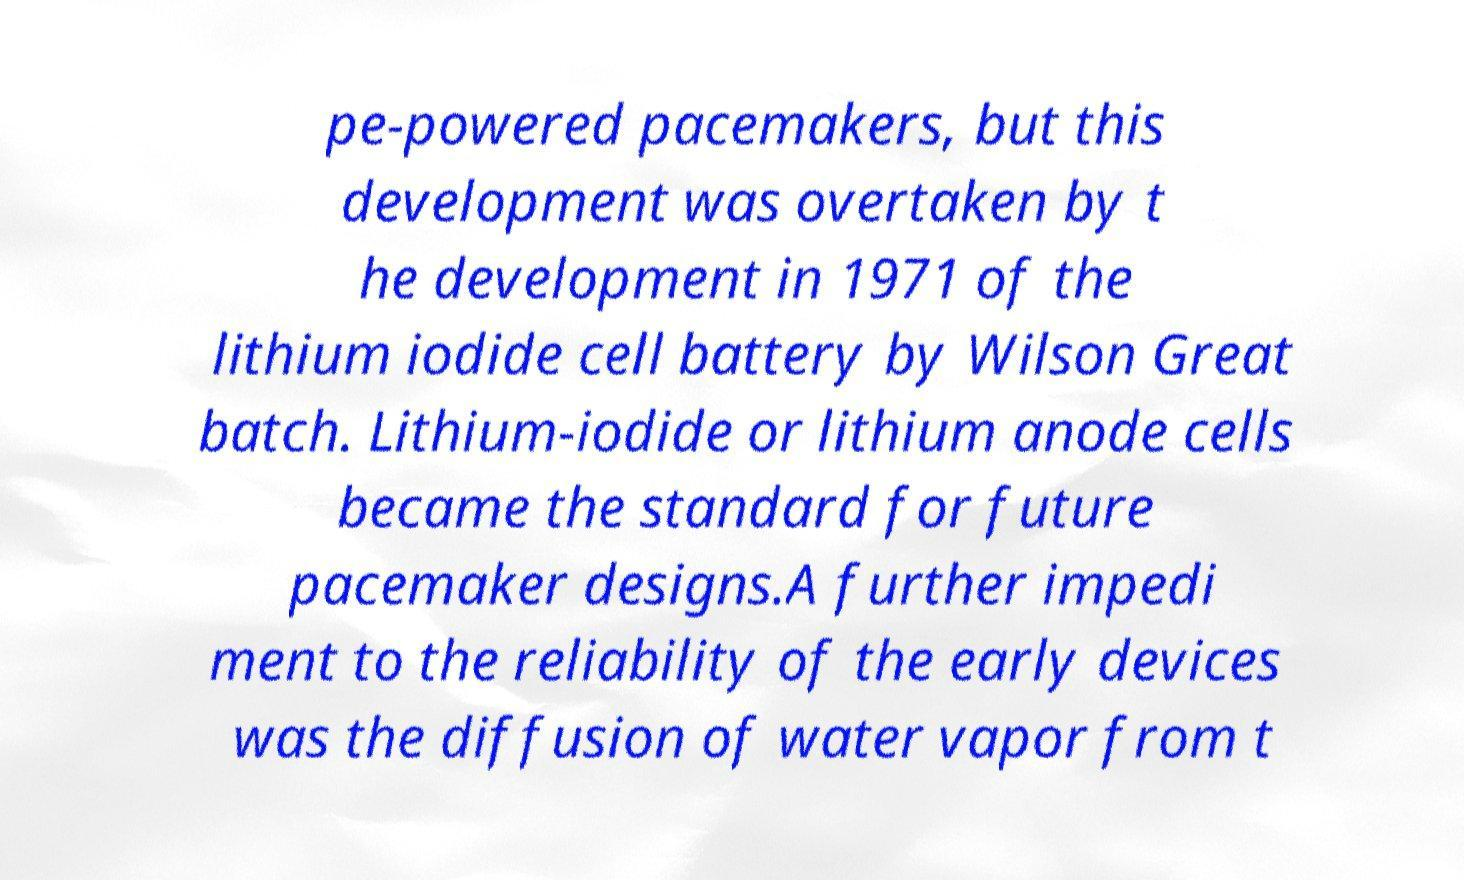Please identify and transcribe the text found in this image. pe-powered pacemakers, but this development was overtaken by t he development in 1971 of the lithium iodide cell battery by Wilson Great batch. Lithium-iodide or lithium anode cells became the standard for future pacemaker designs.A further impedi ment to the reliability of the early devices was the diffusion of water vapor from t 